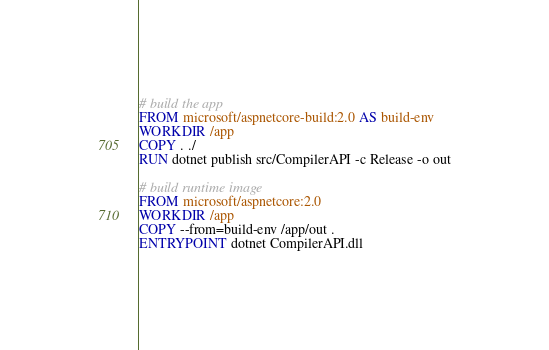Convert code to text. <code><loc_0><loc_0><loc_500><loc_500><_Dockerfile_># build the app
FROM microsoft/aspnetcore-build:2.0 AS build-env
WORKDIR /app
COPY . ./
RUN dotnet publish src/CompilerAPI -c Release -o out

# build runtime image
FROM microsoft/aspnetcore:2.0
WORKDIR /app
COPY --from=build-env /app/out .
ENTRYPOINT dotnet CompilerAPI.dll
</code> 